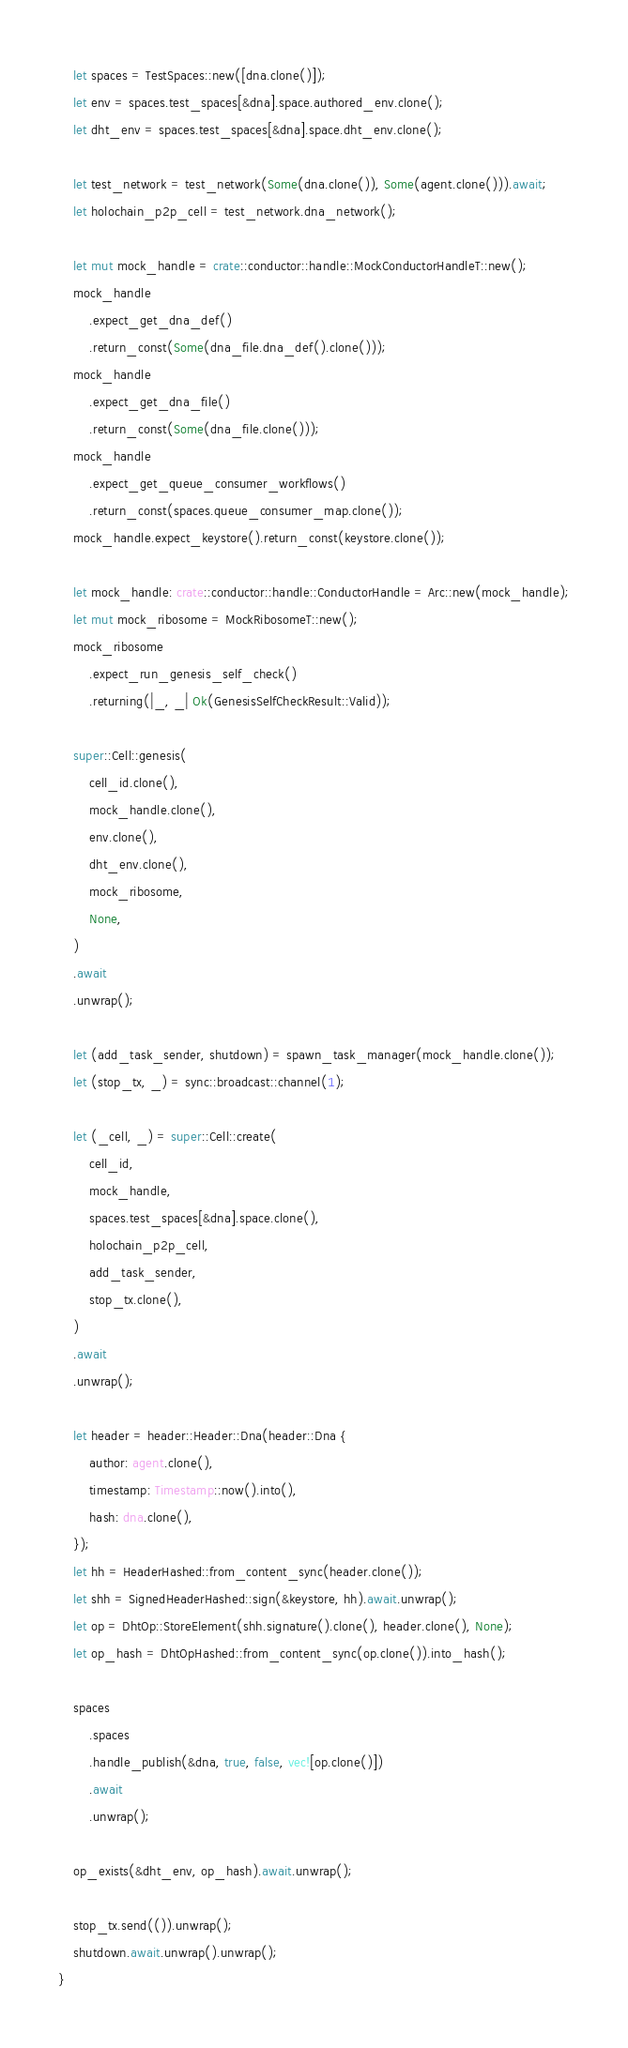<code> <loc_0><loc_0><loc_500><loc_500><_Rust_>
    let spaces = TestSpaces::new([dna.clone()]);
    let env = spaces.test_spaces[&dna].space.authored_env.clone();
    let dht_env = spaces.test_spaces[&dna].space.dht_env.clone();

    let test_network = test_network(Some(dna.clone()), Some(agent.clone())).await;
    let holochain_p2p_cell = test_network.dna_network();

    let mut mock_handle = crate::conductor::handle::MockConductorHandleT::new();
    mock_handle
        .expect_get_dna_def()
        .return_const(Some(dna_file.dna_def().clone()));
    mock_handle
        .expect_get_dna_file()
        .return_const(Some(dna_file.clone()));
    mock_handle
        .expect_get_queue_consumer_workflows()
        .return_const(spaces.queue_consumer_map.clone());
    mock_handle.expect_keystore().return_const(keystore.clone());

    let mock_handle: crate::conductor::handle::ConductorHandle = Arc::new(mock_handle);
    let mut mock_ribosome = MockRibosomeT::new();
    mock_ribosome
        .expect_run_genesis_self_check()
        .returning(|_, _| Ok(GenesisSelfCheckResult::Valid));

    super::Cell::genesis(
        cell_id.clone(),
        mock_handle.clone(),
        env.clone(),
        dht_env.clone(),
        mock_ribosome,
        None,
    )
    .await
    .unwrap();

    let (add_task_sender, shutdown) = spawn_task_manager(mock_handle.clone());
    let (stop_tx, _) = sync::broadcast::channel(1);

    let (_cell, _) = super::Cell::create(
        cell_id,
        mock_handle,
        spaces.test_spaces[&dna].space.clone(),
        holochain_p2p_cell,
        add_task_sender,
        stop_tx.clone(),
    )
    .await
    .unwrap();

    let header = header::Header::Dna(header::Dna {
        author: agent.clone(),
        timestamp: Timestamp::now().into(),
        hash: dna.clone(),
    });
    let hh = HeaderHashed::from_content_sync(header.clone());
    let shh = SignedHeaderHashed::sign(&keystore, hh).await.unwrap();
    let op = DhtOp::StoreElement(shh.signature().clone(), header.clone(), None);
    let op_hash = DhtOpHashed::from_content_sync(op.clone()).into_hash();

    spaces
        .spaces
        .handle_publish(&dna, true, false, vec![op.clone()])
        .await
        .unwrap();

    op_exists(&dht_env, op_hash).await.unwrap();

    stop_tx.send(()).unwrap();
    shutdown.await.unwrap().unwrap();
}
</code> 